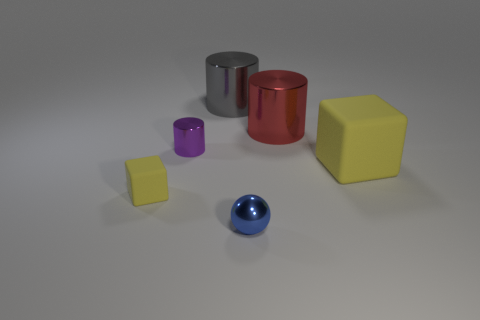Add 1 large yellow shiny cylinders. How many objects exist? 7 Subtract all spheres. How many objects are left? 5 Subtract 0 yellow cylinders. How many objects are left? 6 Subtract all big cylinders. Subtract all big cyan metallic spheres. How many objects are left? 4 Add 5 cylinders. How many cylinders are left? 8 Add 6 rubber objects. How many rubber objects exist? 8 